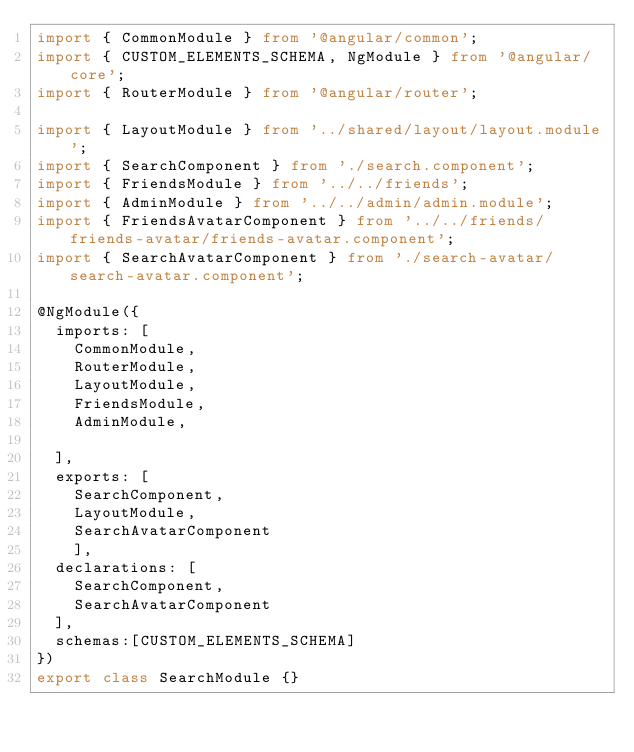<code> <loc_0><loc_0><loc_500><loc_500><_TypeScript_>import { CommonModule } from '@angular/common';
import { CUSTOM_ELEMENTS_SCHEMA, NgModule } from '@angular/core';
import { RouterModule } from '@angular/router';

import { LayoutModule } from '../shared/layout/layout.module';
import { SearchComponent } from './search.component';
import { FriendsModule } from '../../friends';
import { AdminModule } from '../../admin/admin.module';
import { FriendsAvatarComponent } from '../../friends/friends-avatar/friends-avatar.component';
import { SearchAvatarComponent } from './search-avatar/search-avatar.component';

@NgModule({
  imports: [
    CommonModule,
    RouterModule,
    LayoutModule,
    FriendsModule,
    AdminModule,
  
  ],
  exports: [
    SearchComponent,
    LayoutModule,
    SearchAvatarComponent
    ],
  declarations: [
    SearchComponent,
    SearchAvatarComponent
  ],
  schemas:[CUSTOM_ELEMENTS_SCHEMA]
})
export class SearchModule {}
</code> 